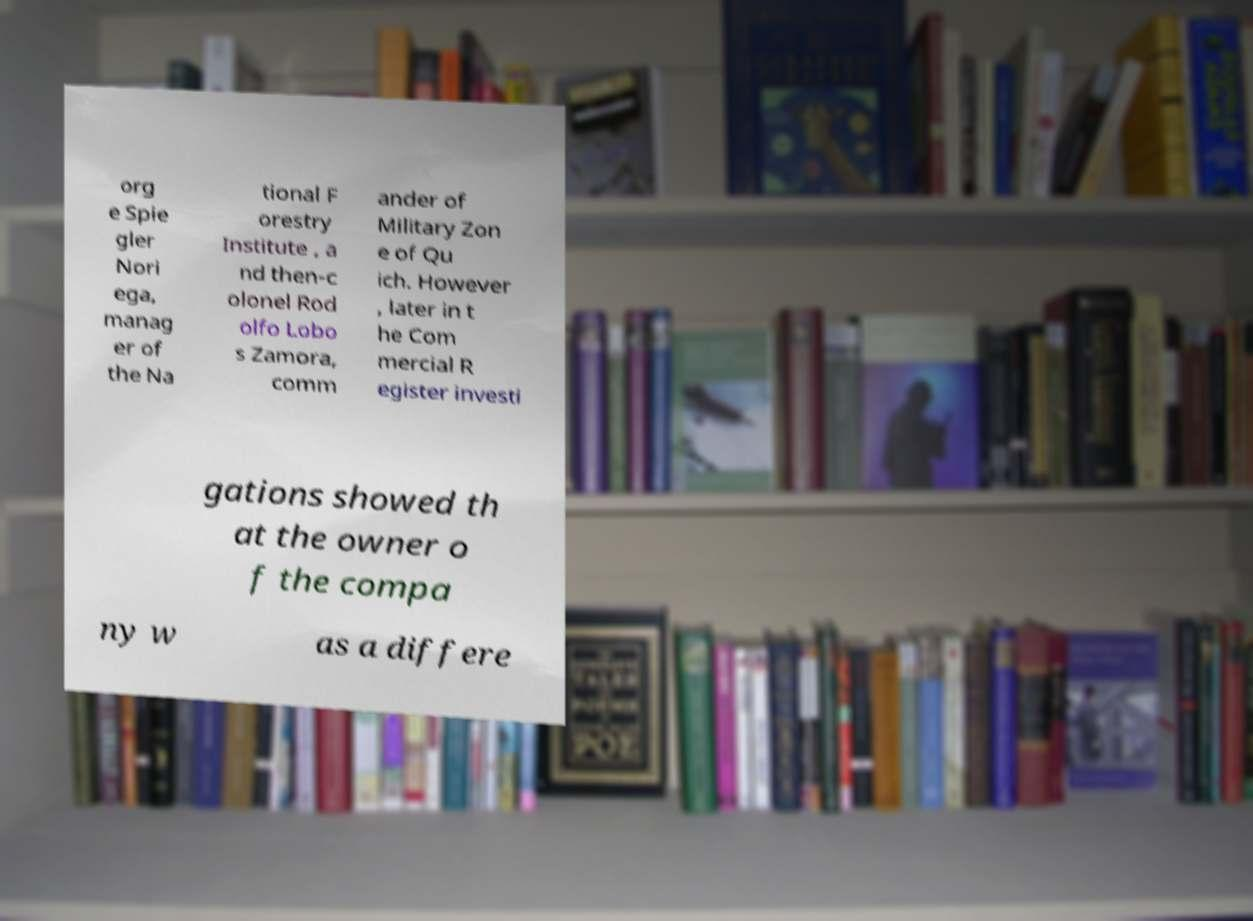Could you extract and type out the text from this image? org e Spie gler Nori ega, manag er of the Na tional F orestry Institute , a nd then-c olonel Rod olfo Lobo s Zamora, comm ander of Military Zon e of Qu ich. However , later in t he Com mercial R egister investi gations showed th at the owner o f the compa ny w as a differe 